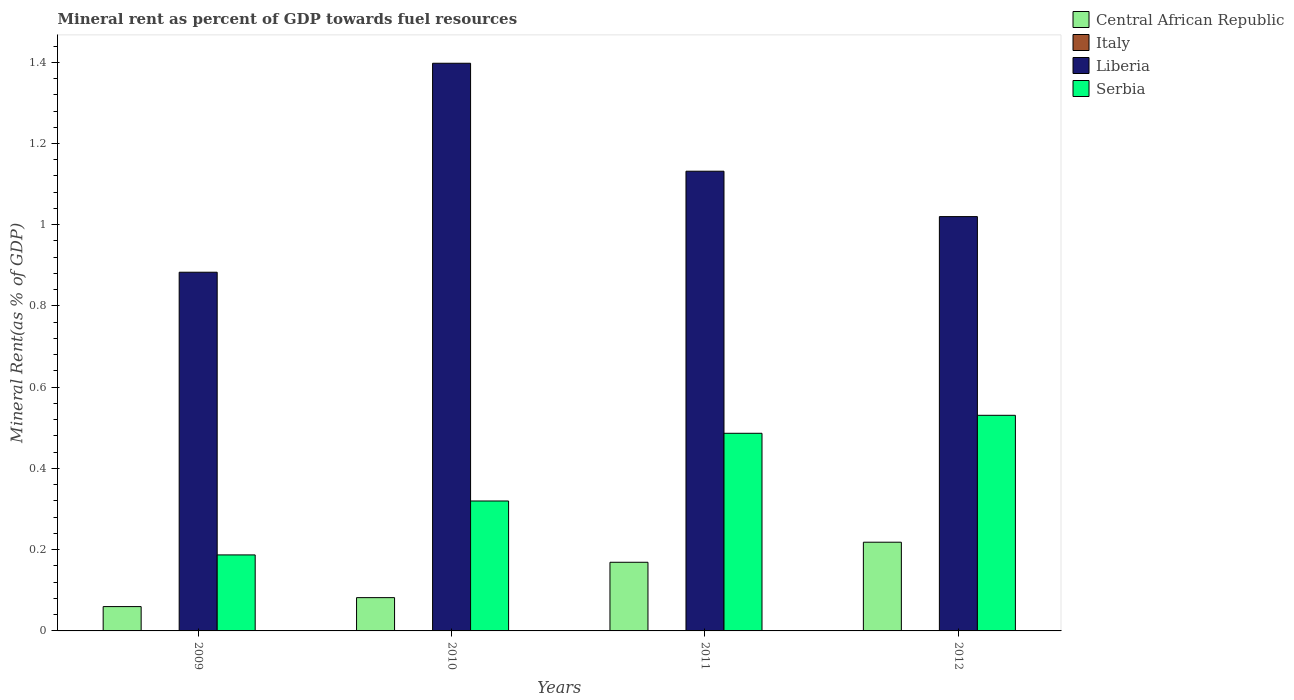How many different coloured bars are there?
Your answer should be very brief. 4. How many groups of bars are there?
Your response must be concise. 4. Are the number of bars on each tick of the X-axis equal?
Ensure brevity in your answer.  Yes. How many bars are there on the 4th tick from the left?
Keep it short and to the point. 4. What is the label of the 2nd group of bars from the left?
Offer a very short reply. 2010. In how many cases, is the number of bars for a given year not equal to the number of legend labels?
Give a very brief answer. 0. What is the mineral rent in Central African Republic in 2011?
Provide a short and direct response. 0.17. Across all years, what is the maximum mineral rent in Italy?
Offer a terse response. 0. Across all years, what is the minimum mineral rent in Central African Republic?
Give a very brief answer. 0.06. In which year was the mineral rent in Liberia maximum?
Your answer should be very brief. 2010. What is the total mineral rent in Italy in the graph?
Provide a succinct answer. 0. What is the difference between the mineral rent in Liberia in 2011 and that in 2012?
Your response must be concise. 0.11. What is the difference between the mineral rent in Central African Republic in 2010 and the mineral rent in Serbia in 2009?
Your response must be concise. -0.11. What is the average mineral rent in Liberia per year?
Make the answer very short. 1.11. In the year 2011, what is the difference between the mineral rent in Serbia and mineral rent in Central African Republic?
Make the answer very short. 0.32. In how many years, is the mineral rent in Central African Republic greater than 0.4 %?
Keep it short and to the point. 0. What is the ratio of the mineral rent in Liberia in 2010 to that in 2012?
Your answer should be very brief. 1.37. Is the mineral rent in Italy in 2011 less than that in 2012?
Offer a terse response. Yes. What is the difference between the highest and the second highest mineral rent in Central African Republic?
Keep it short and to the point. 0.05. What is the difference between the highest and the lowest mineral rent in Central African Republic?
Offer a very short reply. 0.16. In how many years, is the mineral rent in Italy greater than the average mineral rent in Italy taken over all years?
Ensure brevity in your answer.  2. What does the 4th bar from the left in 2009 represents?
Ensure brevity in your answer.  Serbia. What does the 2nd bar from the right in 2009 represents?
Offer a very short reply. Liberia. Is it the case that in every year, the sum of the mineral rent in Serbia and mineral rent in Liberia is greater than the mineral rent in Central African Republic?
Keep it short and to the point. Yes. How many bars are there?
Your answer should be very brief. 16. Are all the bars in the graph horizontal?
Provide a short and direct response. No. Are the values on the major ticks of Y-axis written in scientific E-notation?
Make the answer very short. No. Does the graph contain any zero values?
Your answer should be very brief. No. What is the title of the graph?
Offer a very short reply. Mineral rent as percent of GDP towards fuel resources. Does "Ethiopia" appear as one of the legend labels in the graph?
Provide a short and direct response. No. What is the label or title of the Y-axis?
Ensure brevity in your answer.  Mineral Rent(as % of GDP). What is the Mineral Rent(as % of GDP) of Central African Republic in 2009?
Provide a succinct answer. 0.06. What is the Mineral Rent(as % of GDP) in Italy in 2009?
Provide a short and direct response. 0. What is the Mineral Rent(as % of GDP) in Liberia in 2009?
Your response must be concise. 0.88. What is the Mineral Rent(as % of GDP) of Serbia in 2009?
Your answer should be compact. 0.19. What is the Mineral Rent(as % of GDP) in Central African Republic in 2010?
Your response must be concise. 0.08. What is the Mineral Rent(as % of GDP) in Italy in 2010?
Give a very brief answer. 0. What is the Mineral Rent(as % of GDP) of Liberia in 2010?
Your response must be concise. 1.4. What is the Mineral Rent(as % of GDP) in Serbia in 2010?
Your answer should be compact. 0.32. What is the Mineral Rent(as % of GDP) in Central African Republic in 2011?
Ensure brevity in your answer.  0.17. What is the Mineral Rent(as % of GDP) in Italy in 2011?
Offer a terse response. 0. What is the Mineral Rent(as % of GDP) in Liberia in 2011?
Your response must be concise. 1.13. What is the Mineral Rent(as % of GDP) in Serbia in 2011?
Offer a terse response. 0.49. What is the Mineral Rent(as % of GDP) in Central African Republic in 2012?
Ensure brevity in your answer.  0.22. What is the Mineral Rent(as % of GDP) of Italy in 2012?
Provide a short and direct response. 0. What is the Mineral Rent(as % of GDP) in Liberia in 2012?
Provide a succinct answer. 1.02. What is the Mineral Rent(as % of GDP) of Serbia in 2012?
Give a very brief answer. 0.53. Across all years, what is the maximum Mineral Rent(as % of GDP) in Central African Republic?
Give a very brief answer. 0.22. Across all years, what is the maximum Mineral Rent(as % of GDP) in Italy?
Offer a very short reply. 0. Across all years, what is the maximum Mineral Rent(as % of GDP) of Liberia?
Offer a terse response. 1.4. Across all years, what is the maximum Mineral Rent(as % of GDP) in Serbia?
Your response must be concise. 0.53. Across all years, what is the minimum Mineral Rent(as % of GDP) of Central African Republic?
Provide a succinct answer. 0.06. Across all years, what is the minimum Mineral Rent(as % of GDP) in Italy?
Your answer should be very brief. 0. Across all years, what is the minimum Mineral Rent(as % of GDP) of Liberia?
Offer a terse response. 0.88. Across all years, what is the minimum Mineral Rent(as % of GDP) in Serbia?
Give a very brief answer. 0.19. What is the total Mineral Rent(as % of GDP) in Central African Republic in the graph?
Keep it short and to the point. 0.53. What is the total Mineral Rent(as % of GDP) in Italy in the graph?
Offer a very short reply. 0. What is the total Mineral Rent(as % of GDP) in Liberia in the graph?
Your answer should be very brief. 4.43. What is the total Mineral Rent(as % of GDP) of Serbia in the graph?
Keep it short and to the point. 1.52. What is the difference between the Mineral Rent(as % of GDP) of Central African Republic in 2009 and that in 2010?
Your answer should be compact. -0.02. What is the difference between the Mineral Rent(as % of GDP) in Italy in 2009 and that in 2010?
Your answer should be compact. -0. What is the difference between the Mineral Rent(as % of GDP) in Liberia in 2009 and that in 2010?
Keep it short and to the point. -0.51. What is the difference between the Mineral Rent(as % of GDP) of Serbia in 2009 and that in 2010?
Provide a short and direct response. -0.13. What is the difference between the Mineral Rent(as % of GDP) of Central African Republic in 2009 and that in 2011?
Make the answer very short. -0.11. What is the difference between the Mineral Rent(as % of GDP) of Italy in 2009 and that in 2011?
Your response must be concise. -0. What is the difference between the Mineral Rent(as % of GDP) of Liberia in 2009 and that in 2011?
Make the answer very short. -0.25. What is the difference between the Mineral Rent(as % of GDP) in Serbia in 2009 and that in 2011?
Offer a terse response. -0.3. What is the difference between the Mineral Rent(as % of GDP) in Central African Republic in 2009 and that in 2012?
Your answer should be very brief. -0.16. What is the difference between the Mineral Rent(as % of GDP) of Italy in 2009 and that in 2012?
Offer a terse response. -0. What is the difference between the Mineral Rent(as % of GDP) in Liberia in 2009 and that in 2012?
Provide a short and direct response. -0.14. What is the difference between the Mineral Rent(as % of GDP) in Serbia in 2009 and that in 2012?
Offer a terse response. -0.34. What is the difference between the Mineral Rent(as % of GDP) of Central African Republic in 2010 and that in 2011?
Provide a short and direct response. -0.09. What is the difference between the Mineral Rent(as % of GDP) in Italy in 2010 and that in 2011?
Keep it short and to the point. -0. What is the difference between the Mineral Rent(as % of GDP) of Liberia in 2010 and that in 2011?
Your response must be concise. 0.27. What is the difference between the Mineral Rent(as % of GDP) in Serbia in 2010 and that in 2011?
Provide a succinct answer. -0.17. What is the difference between the Mineral Rent(as % of GDP) in Central African Republic in 2010 and that in 2012?
Your answer should be very brief. -0.14. What is the difference between the Mineral Rent(as % of GDP) in Italy in 2010 and that in 2012?
Your answer should be very brief. -0. What is the difference between the Mineral Rent(as % of GDP) of Liberia in 2010 and that in 2012?
Your answer should be compact. 0.38. What is the difference between the Mineral Rent(as % of GDP) in Serbia in 2010 and that in 2012?
Offer a very short reply. -0.21. What is the difference between the Mineral Rent(as % of GDP) of Central African Republic in 2011 and that in 2012?
Provide a succinct answer. -0.05. What is the difference between the Mineral Rent(as % of GDP) of Italy in 2011 and that in 2012?
Provide a short and direct response. -0. What is the difference between the Mineral Rent(as % of GDP) in Liberia in 2011 and that in 2012?
Offer a terse response. 0.11. What is the difference between the Mineral Rent(as % of GDP) in Serbia in 2011 and that in 2012?
Offer a terse response. -0.04. What is the difference between the Mineral Rent(as % of GDP) in Central African Republic in 2009 and the Mineral Rent(as % of GDP) in Italy in 2010?
Offer a terse response. 0.06. What is the difference between the Mineral Rent(as % of GDP) in Central African Republic in 2009 and the Mineral Rent(as % of GDP) in Liberia in 2010?
Your response must be concise. -1.34. What is the difference between the Mineral Rent(as % of GDP) in Central African Republic in 2009 and the Mineral Rent(as % of GDP) in Serbia in 2010?
Provide a succinct answer. -0.26. What is the difference between the Mineral Rent(as % of GDP) of Italy in 2009 and the Mineral Rent(as % of GDP) of Liberia in 2010?
Your answer should be compact. -1.4. What is the difference between the Mineral Rent(as % of GDP) in Italy in 2009 and the Mineral Rent(as % of GDP) in Serbia in 2010?
Your response must be concise. -0.32. What is the difference between the Mineral Rent(as % of GDP) of Liberia in 2009 and the Mineral Rent(as % of GDP) of Serbia in 2010?
Your answer should be compact. 0.56. What is the difference between the Mineral Rent(as % of GDP) of Central African Republic in 2009 and the Mineral Rent(as % of GDP) of Italy in 2011?
Your response must be concise. 0.06. What is the difference between the Mineral Rent(as % of GDP) in Central African Republic in 2009 and the Mineral Rent(as % of GDP) in Liberia in 2011?
Offer a very short reply. -1.07. What is the difference between the Mineral Rent(as % of GDP) in Central African Republic in 2009 and the Mineral Rent(as % of GDP) in Serbia in 2011?
Ensure brevity in your answer.  -0.43. What is the difference between the Mineral Rent(as % of GDP) of Italy in 2009 and the Mineral Rent(as % of GDP) of Liberia in 2011?
Provide a succinct answer. -1.13. What is the difference between the Mineral Rent(as % of GDP) in Italy in 2009 and the Mineral Rent(as % of GDP) in Serbia in 2011?
Keep it short and to the point. -0.49. What is the difference between the Mineral Rent(as % of GDP) in Liberia in 2009 and the Mineral Rent(as % of GDP) in Serbia in 2011?
Your answer should be very brief. 0.4. What is the difference between the Mineral Rent(as % of GDP) in Central African Republic in 2009 and the Mineral Rent(as % of GDP) in Italy in 2012?
Give a very brief answer. 0.06. What is the difference between the Mineral Rent(as % of GDP) in Central African Republic in 2009 and the Mineral Rent(as % of GDP) in Liberia in 2012?
Offer a terse response. -0.96. What is the difference between the Mineral Rent(as % of GDP) in Central African Republic in 2009 and the Mineral Rent(as % of GDP) in Serbia in 2012?
Keep it short and to the point. -0.47. What is the difference between the Mineral Rent(as % of GDP) of Italy in 2009 and the Mineral Rent(as % of GDP) of Liberia in 2012?
Provide a short and direct response. -1.02. What is the difference between the Mineral Rent(as % of GDP) in Italy in 2009 and the Mineral Rent(as % of GDP) in Serbia in 2012?
Offer a terse response. -0.53. What is the difference between the Mineral Rent(as % of GDP) of Liberia in 2009 and the Mineral Rent(as % of GDP) of Serbia in 2012?
Provide a succinct answer. 0.35. What is the difference between the Mineral Rent(as % of GDP) in Central African Republic in 2010 and the Mineral Rent(as % of GDP) in Italy in 2011?
Your answer should be compact. 0.08. What is the difference between the Mineral Rent(as % of GDP) in Central African Republic in 2010 and the Mineral Rent(as % of GDP) in Liberia in 2011?
Your response must be concise. -1.05. What is the difference between the Mineral Rent(as % of GDP) of Central African Republic in 2010 and the Mineral Rent(as % of GDP) of Serbia in 2011?
Your answer should be compact. -0.4. What is the difference between the Mineral Rent(as % of GDP) in Italy in 2010 and the Mineral Rent(as % of GDP) in Liberia in 2011?
Ensure brevity in your answer.  -1.13. What is the difference between the Mineral Rent(as % of GDP) in Italy in 2010 and the Mineral Rent(as % of GDP) in Serbia in 2011?
Make the answer very short. -0.49. What is the difference between the Mineral Rent(as % of GDP) in Liberia in 2010 and the Mineral Rent(as % of GDP) in Serbia in 2011?
Your answer should be very brief. 0.91. What is the difference between the Mineral Rent(as % of GDP) in Central African Republic in 2010 and the Mineral Rent(as % of GDP) in Italy in 2012?
Keep it short and to the point. 0.08. What is the difference between the Mineral Rent(as % of GDP) in Central African Republic in 2010 and the Mineral Rent(as % of GDP) in Liberia in 2012?
Offer a very short reply. -0.94. What is the difference between the Mineral Rent(as % of GDP) of Central African Republic in 2010 and the Mineral Rent(as % of GDP) of Serbia in 2012?
Give a very brief answer. -0.45. What is the difference between the Mineral Rent(as % of GDP) of Italy in 2010 and the Mineral Rent(as % of GDP) of Liberia in 2012?
Keep it short and to the point. -1.02. What is the difference between the Mineral Rent(as % of GDP) of Italy in 2010 and the Mineral Rent(as % of GDP) of Serbia in 2012?
Keep it short and to the point. -0.53. What is the difference between the Mineral Rent(as % of GDP) in Liberia in 2010 and the Mineral Rent(as % of GDP) in Serbia in 2012?
Provide a short and direct response. 0.87. What is the difference between the Mineral Rent(as % of GDP) in Central African Republic in 2011 and the Mineral Rent(as % of GDP) in Italy in 2012?
Keep it short and to the point. 0.17. What is the difference between the Mineral Rent(as % of GDP) of Central African Republic in 2011 and the Mineral Rent(as % of GDP) of Liberia in 2012?
Provide a succinct answer. -0.85. What is the difference between the Mineral Rent(as % of GDP) of Central African Republic in 2011 and the Mineral Rent(as % of GDP) of Serbia in 2012?
Your answer should be compact. -0.36. What is the difference between the Mineral Rent(as % of GDP) of Italy in 2011 and the Mineral Rent(as % of GDP) of Liberia in 2012?
Offer a very short reply. -1.02. What is the difference between the Mineral Rent(as % of GDP) of Italy in 2011 and the Mineral Rent(as % of GDP) of Serbia in 2012?
Provide a succinct answer. -0.53. What is the difference between the Mineral Rent(as % of GDP) of Liberia in 2011 and the Mineral Rent(as % of GDP) of Serbia in 2012?
Provide a succinct answer. 0.6. What is the average Mineral Rent(as % of GDP) in Central African Republic per year?
Your answer should be compact. 0.13. What is the average Mineral Rent(as % of GDP) of Italy per year?
Offer a very short reply. 0. What is the average Mineral Rent(as % of GDP) in Liberia per year?
Keep it short and to the point. 1.11. What is the average Mineral Rent(as % of GDP) in Serbia per year?
Provide a short and direct response. 0.38. In the year 2009, what is the difference between the Mineral Rent(as % of GDP) of Central African Republic and Mineral Rent(as % of GDP) of Italy?
Offer a very short reply. 0.06. In the year 2009, what is the difference between the Mineral Rent(as % of GDP) in Central African Republic and Mineral Rent(as % of GDP) in Liberia?
Make the answer very short. -0.82. In the year 2009, what is the difference between the Mineral Rent(as % of GDP) in Central African Republic and Mineral Rent(as % of GDP) in Serbia?
Your answer should be very brief. -0.13. In the year 2009, what is the difference between the Mineral Rent(as % of GDP) in Italy and Mineral Rent(as % of GDP) in Liberia?
Make the answer very short. -0.88. In the year 2009, what is the difference between the Mineral Rent(as % of GDP) in Italy and Mineral Rent(as % of GDP) in Serbia?
Your answer should be very brief. -0.19. In the year 2009, what is the difference between the Mineral Rent(as % of GDP) of Liberia and Mineral Rent(as % of GDP) of Serbia?
Ensure brevity in your answer.  0.7. In the year 2010, what is the difference between the Mineral Rent(as % of GDP) of Central African Republic and Mineral Rent(as % of GDP) of Italy?
Give a very brief answer. 0.08. In the year 2010, what is the difference between the Mineral Rent(as % of GDP) of Central African Republic and Mineral Rent(as % of GDP) of Liberia?
Your answer should be compact. -1.32. In the year 2010, what is the difference between the Mineral Rent(as % of GDP) of Central African Republic and Mineral Rent(as % of GDP) of Serbia?
Your answer should be compact. -0.24. In the year 2010, what is the difference between the Mineral Rent(as % of GDP) of Italy and Mineral Rent(as % of GDP) of Liberia?
Offer a very short reply. -1.4. In the year 2010, what is the difference between the Mineral Rent(as % of GDP) of Italy and Mineral Rent(as % of GDP) of Serbia?
Provide a short and direct response. -0.32. In the year 2010, what is the difference between the Mineral Rent(as % of GDP) in Liberia and Mineral Rent(as % of GDP) in Serbia?
Offer a terse response. 1.08. In the year 2011, what is the difference between the Mineral Rent(as % of GDP) of Central African Republic and Mineral Rent(as % of GDP) of Italy?
Give a very brief answer. 0.17. In the year 2011, what is the difference between the Mineral Rent(as % of GDP) in Central African Republic and Mineral Rent(as % of GDP) in Liberia?
Give a very brief answer. -0.96. In the year 2011, what is the difference between the Mineral Rent(as % of GDP) of Central African Republic and Mineral Rent(as % of GDP) of Serbia?
Your answer should be very brief. -0.32. In the year 2011, what is the difference between the Mineral Rent(as % of GDP) of Italy and Mineral Rent(as % of GDP) of Liberia?
Your response must be concise. -1.13. In the year 2011, what is the difference between the Mineral Rent(as % of GDP) of Italy and Mineral Rent(as % of GDP) of Serbia?
Make the answer very short. -0.49. In the year 2011, what is the difference between the Mineral Rent(as % of GDP) in Liberia and Mineral Rent(as % of GDP) in Serbia?
Keep it short and to the point. 0.65. In the year 2012, what is the difference between the Mineral Rent(as % of GDP) in Central African Republic and Mineral Rent(as % of GDP) in Italy?
Offer a very short reply. 0.22. In the year 2012, what is the difference between the Mineral Rent(as % of GDP) in Central African Republic and Mineral Rent(as % of GDP) in Liberia?
Provide a short and direct response. -0.8. In the year 2012, what is the difference between the Mineral Rent(as % of GDP) of Central African Republic and Mineral Rent(as % of GDP) of Serbia?
Provide a short and direct response. -0.31. In the year 2012, what is the difference between the Mineral Rent(as % of GDP) in Italy and Mineral Rent(as % of GDP) in Liberia?
Your answer should be compact. -1.02. In the year 2012, what is the difference between the Mineral Rent(as % of GDP) of Italy and Mineral Rent(as % of GDP) of Serbia?
Keep it short and to the point. -0.53. In the year 2012, what is the difference between the Mineral Rent(as % of GDP) in Liberia and Mineral Rent(as % of GDP) in Serbia?
Offer a very short reply. 0.49. What is the ratio of the Mineral Rent(as % of GDP) of Central African Republic in 2009 to that in 2010?
Provide a succinct answer. 0.73. What is the ratio of the Mineral Rent(as % of GDP) of Italy in 2009 to that in 2010?
Make the answer very short. 0.71. What is the ratio of the Mineral Rent(as % of GDP) of Liberia in 2009 to that in 2010?
Your answer should be compact. 0.63. What is the ratio of the Mineral Rent(as % of GDP) of Serbia in 2009 to that in 2010?
Keep it short and to the point. 0.58. What is the ratio of the Mineral Rent(as % of GDP) of Central African Republic in 2009 to that in 2011?
Ensure brevity in your answer.  0.35. What is the ratio of the Mineral Rent(as % of GDP) of Italy in 2009 to that in 2011?
Offer a terse response. 0.57. What is the ratio of the Mineral Rent(as % of GDP) of Liberia in 2009 to that in 2011?
Make the answer very short. 0.78. What is the ratio of the Mineral Rent(as % of GDP) in Serbia in 2009 to that in 2011?
Your answer should be compact. 0.38. What is the ratio of the Mineral Rent(as % of GDP) in Central African Republic in 2009 to that in 2012?
Offer a very short reply. 0.27. What is the ratio of the Mineral Rent(as % of GDP) in Italy in 2009 to that in 2012?
Offer a terse response. 0.48. What is the ratio of the Mineral Rent(as % of GDP) in Liberia in 2009 to that in 2012?
Your answer should be very brief. 0.87. What is the ratio of the Mineral Rent(as % of GDP) in Serbia in 2009 to that in 2012?
Ensure brevity in your answer.  0.35. What is the ratio of the Mineral Rent(as % of GDP) of Central African Republic in 2010 to that in 2011?
Ensure brevity in your answer.  0.48. What is the ratio of the Mineral Rent(as % of GDP) in Italy in 2010 to that in 2011?
Provide a succinct answer. 0.8. What is the ratio of the Mineral Rent(as % of GDP) in Liberia in 2010 to that in 2011?
Offer a very short reply. 1.23. What is the ratio of the Mineral Rent(as % of GDP) of Serbia in 2010 to that in 2011?
Offer a very short reply. 0.66. What is the ratio of the Mineral Rent(as % of GDP) of Central African Republic in 2010 to that in 2012?
Keep it short and to the point. 0.38. What is the ratio of the Mineral Rent(as % of GDP) of Italy in 2010 to that in 2012?
Ensure brevity in your answer.  0.68. What is the ratio of the Mineral Rent(as % of GDP) of Liberia in 2010 to that in 2012?
Ensure brevity in your answer.  1.37. What is the ratio of the Mineral Rent(as % of GDP) in Serbia in 2010 to that in 2012?
Ensure brevity in your answer.  0.6. What is the ratio of the Mineral Rent(as % of GDP) of Central African Republic in 2011 to that in 2012?
Your answer should be compact. 0.77. What is the ratio of the Mineral Rent(as % of GDP) in Italy in 2011 to that in 2012?
Provide a short and direct response. 0.85. What is the ratio of the Mineral Rent(as % of GDP) of Liberia in 2011 to that in 2012?
Provide a short and direct response. 1.11. What is the ratio of the Mineral Rent(as % of GDP) of Serbia in 2011 to that in 2012?
Offer a terse response. 0.92. What is the difference between the highest and the second highest Mineral Rent(as % of GDP) of Central African Republic?
Provide a short and direct response. 0.05. What is the difference between the highest and the second highest Mineral Rent(as % of GDP) in Liberia?
Offer a terse response. 0.27. What is the difference between the highest and the second highest Mineral Rent(as % of GDP) of Serbia?
Ensure brevity in your answer.  0.04. What is the difference between the highest and the lowest Mineral Rent(as % of GDP) of Central African Republic?
Keep it short and to the point. 0.16. What is the difference between the highest and the lowest Mineral Rent(as % of GDP) in Liberia?
Make the answer very short. 0.51. What is the difference between the highest and the lowest Mineral Rent(as % of GDP) of Serbia?
Make the answer very short. 0.34. 